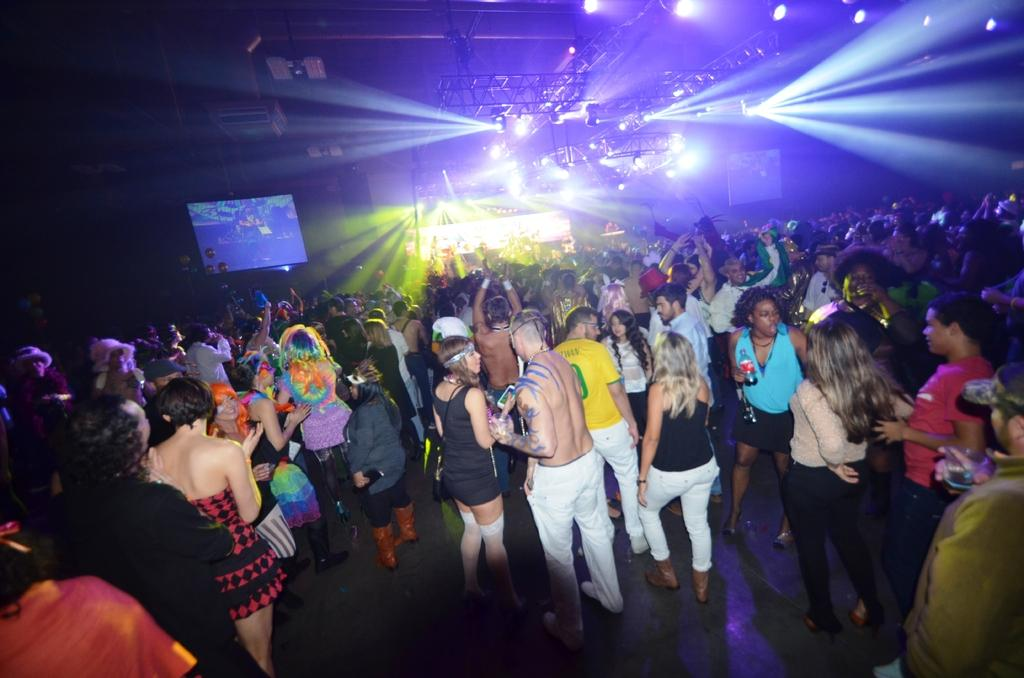Who or what is present in the image? There are people in the image. What are some of the people doing in the image? Some people are lifting their hands. What objects can be seen in the image besides the people? There are screens and lights on the roof in the image. What type of leaf is being used as a prop in the image? There is no leaf present in the image. What kind of joke is being told by the people in the image? There is no indication of a joke being told in the image. 